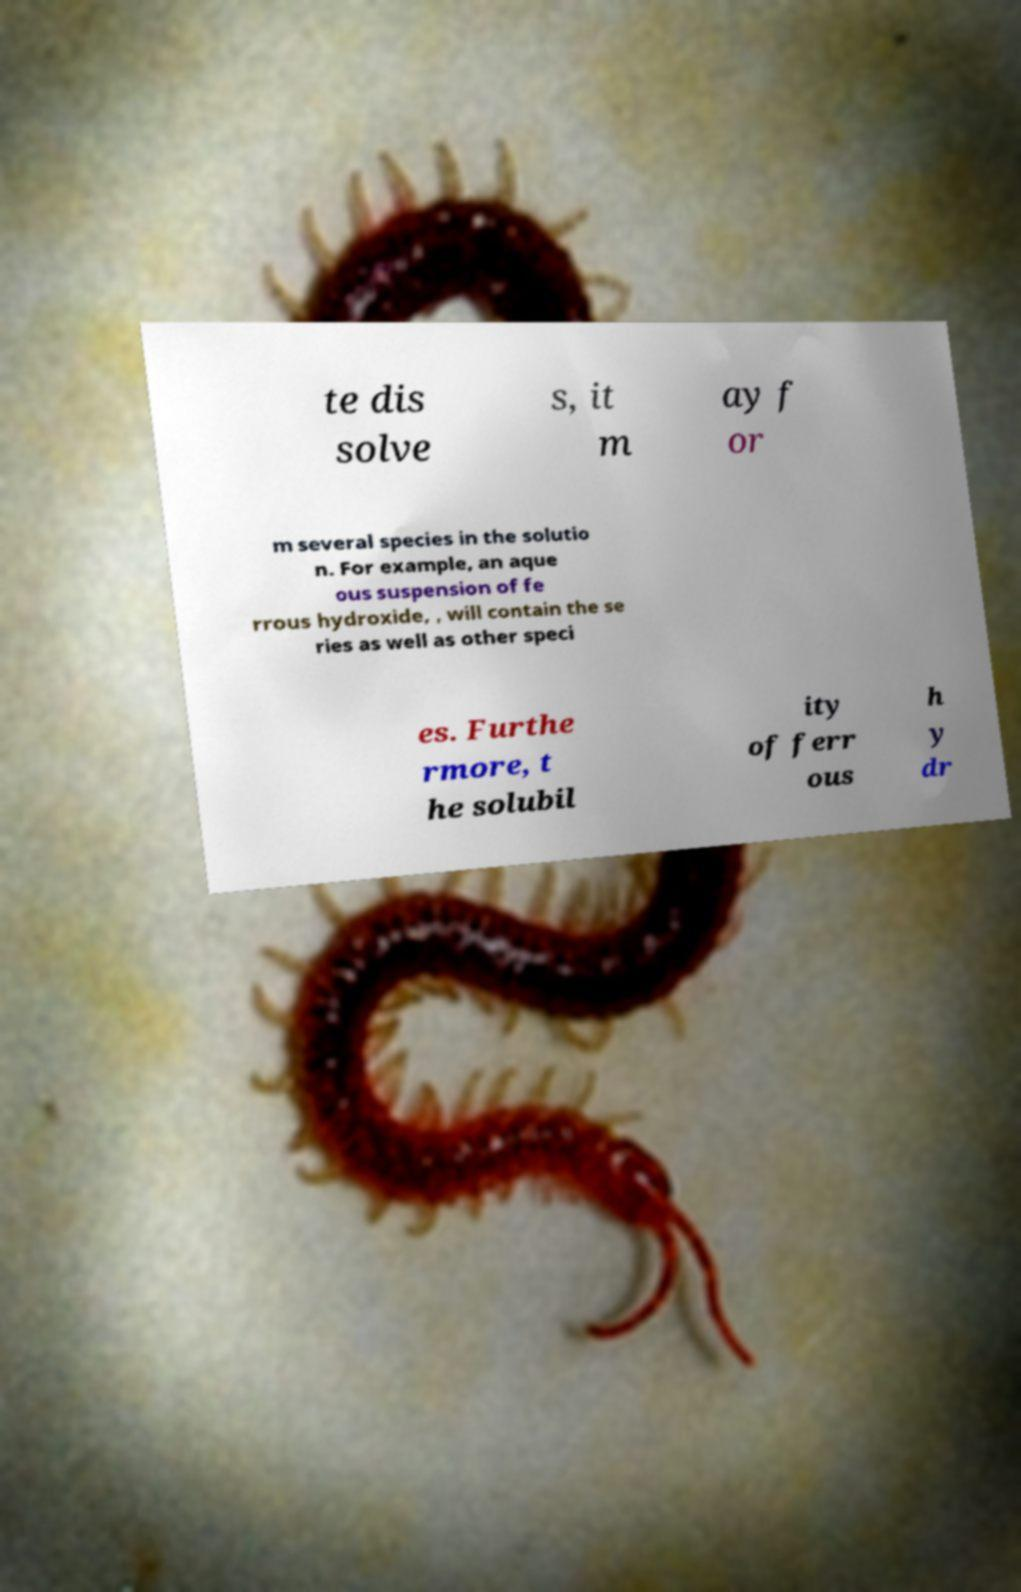I need the written content from this picture converted into text. Can you do that? te dis solve s, it m ay f or m several species in the solutio n. For example, an aque ous suspension of fe rrous hydroxide, , will contain the se ries as well as other speci es. Furthe rmore, t he solubil ity of ferr ous h y dr 